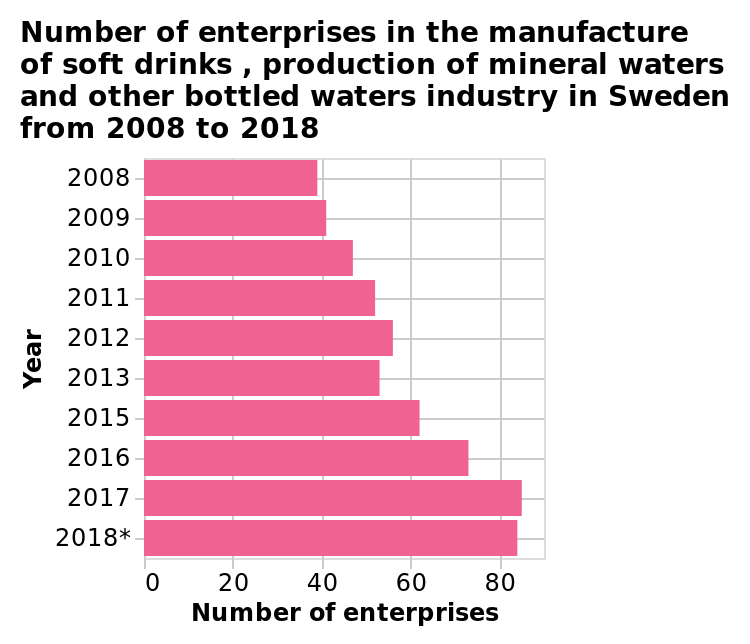<image>
How has the number of enterprises changed over time?  The number of enterprises has gradually increased from 2008 and then decreased in 2018. What does the bar diagram represent? The bar diagram represents the number of enterprises in the manufacture of soft drinks, production of mineral waters, and other bottled waters industry in Sweden from 2008 to 2018. 